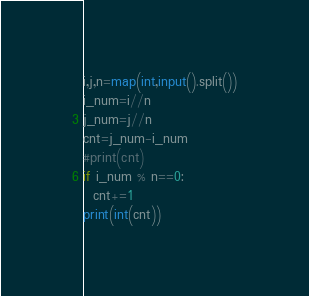Convert code to text. <code><loc_0><loc_0><loc_500><loc_500><_Python_>i,j,n=map(int,input().split())
i_num=i//n
j_num=j//n
cnt=j_num-i_num
#print(cnt)
if i_num % n==0:
  cnt+=1
print(int(cnt))
</code> 